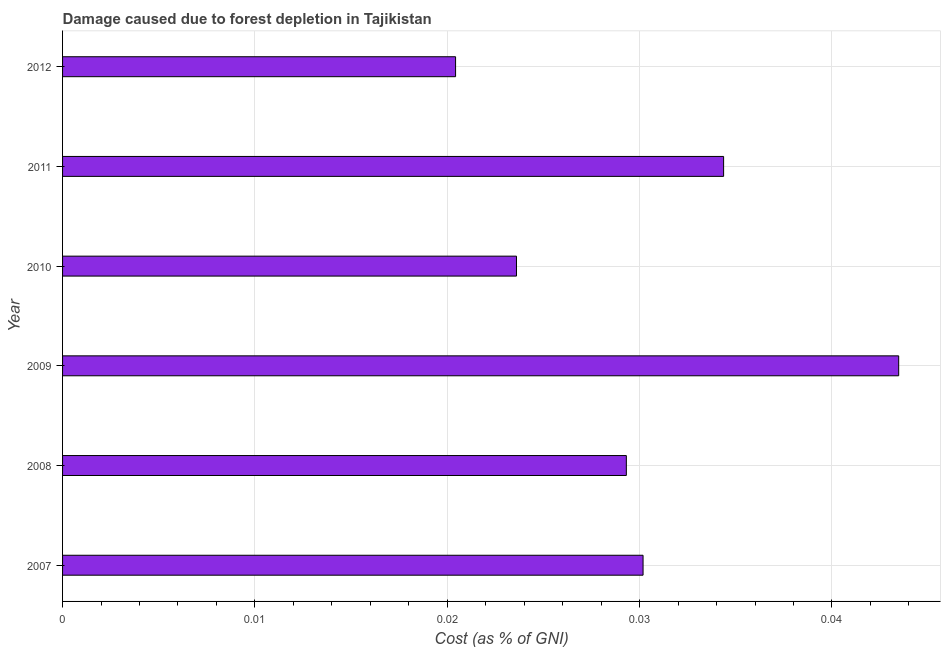Does the graph contain any zero values?
Ensure brevity in your answer.  No. Does the graph contain grids?
Keep it short and to the point. Yes. What is the title of the graph?
Your answer should be compact. Damage caused due to forest depletion in Tajikistan. What is the label or title of the X-axis?
Keep it short and to the point. Cost (as % of GNI). What is the label or title of the Y-axis?
Make the answer very short. Year. What is the damage caused due to forest depletion in 2011?
Your answer should be very brief. 0.03. Across all years, what is the maximum damage caused due to forest depletion?
Provide a short and direct response. 0.04. Across all years, what is the minimum damage caused due to forest depletion?
Keep it short and to the point. 0.02. What is the sum of the damage caused due to forest depletion?
Make the answer very short. 0.18. What is the difference between the damage caused due to forest depletion in 2007 and 2009?
Offer a very short reply. -0.01. What is the average damage caused due to forest depletion per year?
Ensure brevity in your answer.  0.03. What is the median damage caused due to forest depletion?
Ensure brevity in your answer.  0.03. In how many years, is the damage caused due to forest depletion greater than 0.008 %?
Make the answer very short. 6. What is the ratio of the damage caused due to forest depletion in 2008 to that in 2009?
Give a very brief answer. 0.67. Is the difference between the damage caused due to forest depletion in 2007 and 2011 greater than the difference between any two years?
Give a very brief answer. No. What is the difference between the highest and the second highest damage caused due to forest depletion?
Offer a terse response. 0.01. Are all the bars in the graph horizontal?
Your response must be concise. Yes. How many years are there in the graph?
Offer a terse response. 6. What is the Cost (as % of GNI) of 2007?
Keep it short and to the point. 0.03. What is the Cost (as % of GNI) of 2008?
Make the answer very short. 0.03. What is the Cost (as % of GNI) of 2009?
Provide a succinct answer. 0.04. What is the Cost (as % of GNI) of 2010?
Your answer should be compact. 0.02. What is the Cost (as % of GNI) of 2011?
Make the answer very short. 0.03. What is the Cost (as % of GNI) of 2012?
Provide a short and direct response. 0.02. What is the difference between the Cost (as % of GNI) in 2007 and 2008?
Offer a terse response. 0. What is the difference between the Cost (as % of GNI) in 2007 and 2009?
Offer a very short reply. -0.01. What is the difference between the Cost (as % of GNI) in 2007 and 2010?
Keep it short and to the point. 0.01. What is the difference between the Cost (as % of GNI) in 2007 and 2011?
Your answer should be compact. -0. What is the difference between the Cost (as % of GNI) in 2007 and 2012?
Your answer should be very brief. 0.01. What is the difference between the Cost (as % of GNI) in 2008 and 2009?
Your response must be concise. -0.01. What is the difference between the Cost (as % of GNI) in 2008 and 2010?
Provide a short and direct response. 0.01. What is the difference between the Cost (as % of GNI) in 2008 and 2011?
Provide a succinct answer. -0.01. What is the difference between the Cost (as % of GNI) in 2008 and 2012?
Your answer should be compact. 0.01. What is the difference between the Cost (as % of GNI) in 2009 and 2010?
Keep it short and to the point. 0.02. What is the difference between the Cost (as % of GNI) in 2009 and 2011?
Make the answer very short. 0.01. What is the difference between the Cost (as % of GNI) in 2009 and 2012?
Ensure brevity in your answer.  0.02. What is the difference between the Cost (as % of GNI) in 2010 and 2011?
Provide a succinct answer. -0.01. What is the difference between the Cost (as % of GNI) in 2010 and 2012?
Ensure brevity in your answer.  0. What is the difference between the Cost (as % of GNI) in 2011 and 2012?
Ensure brevity in your answer.  0.01. What is the ratio of the Cost (as % of GNI) in 2007 to that in 2009?
Give a very brief answer. 0.69. What is the ratio of the Cost (as % of GNI) in 2007 to that in 2010?
Give a very brief answer. 1.28. What is the ratio of the Cost (as % of GNI) in 2007 to that in 2011?
Offer a terse response. 0.88. What is the ratio of the Cost (as % of GNI) in 2007 to that in 2012?
Your response must be concise. 1.48. What is the ratio of the Cost (as % of GNI) in 2008 to that in 2009?
Keep it short and to the point. 0.67. What is the ratio of the Cost (as % of GNI) in 2008 to that in 2010?
Your response must be concise. 1.24. What is the ratio of the Cost (as % of GNI) in 2008 to that in 2011?
Your answer should be very brief. 0.85. What is the ratio of the Cost (as % of GNI) in 2008 to that in 2012?
Your answer should be very brief. 1.44. What is the ratio of the Cost (as % of GNI) in 2009 to that in 2010?
Make the answer very short. 1.84. What is the ratio of the Cost (as % of GNI) in 2009 to that in 2011?
Your answer should be compact. 1.26. What is the ratio of the Cost (as % of GNI) in 2009 to that in 2012?
Your response must be concise. 2.13. What is the ratio of the Cost (as % of GNI) in 2010 to that in 2011?
Provide a succinct answer. 0.69. What is the ratio of the Cost (as % of GNI) in 2010 to that in 2012?
Your answer should be compact. 1.16. What is the ratio of the Cost (as % of GNI) in 2011 to that in 2012?
Keep it short and to the point. 1.68. 